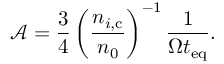Convert formula to latex. <formula><loc_0><loc_0><loc_500><loc_500>\mathcal { A } = \frac { 3 } { 4 } \left ( \frac { n _ { i , c } } { n _ { 0 } } \right ) ^ { - 1 } \frac { 1 } { \Omega t _ { e q } } .</formula> 